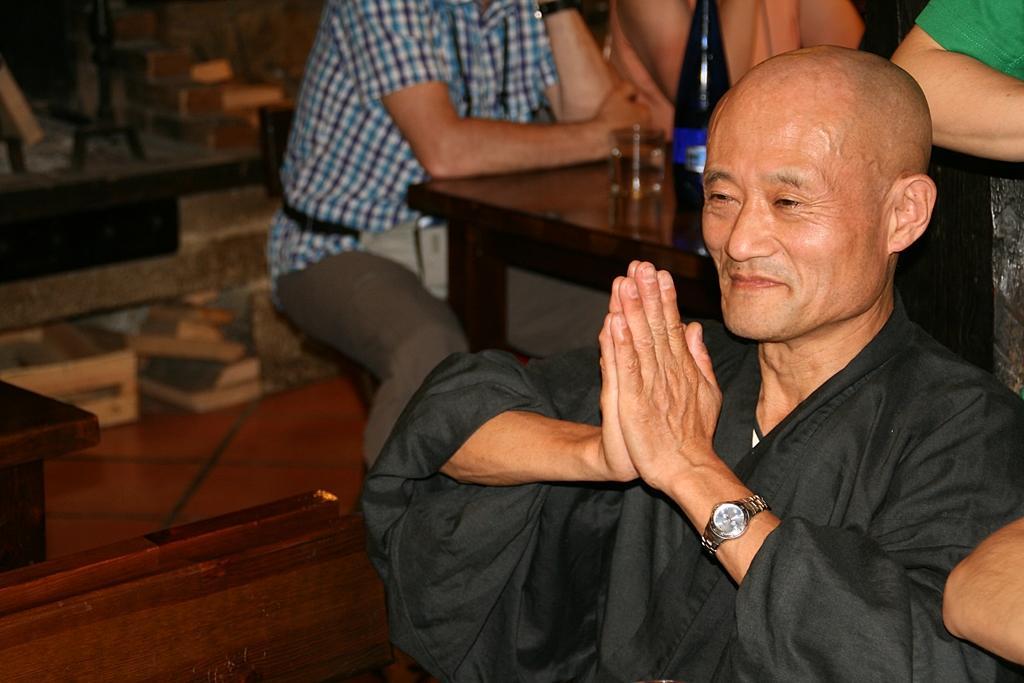Describe this image in one or two sentences. In this image we can see there are people sitting near the table. On the table we can see the bottle and glass. And there are some wooden objects. At the back it looks like a wall. 